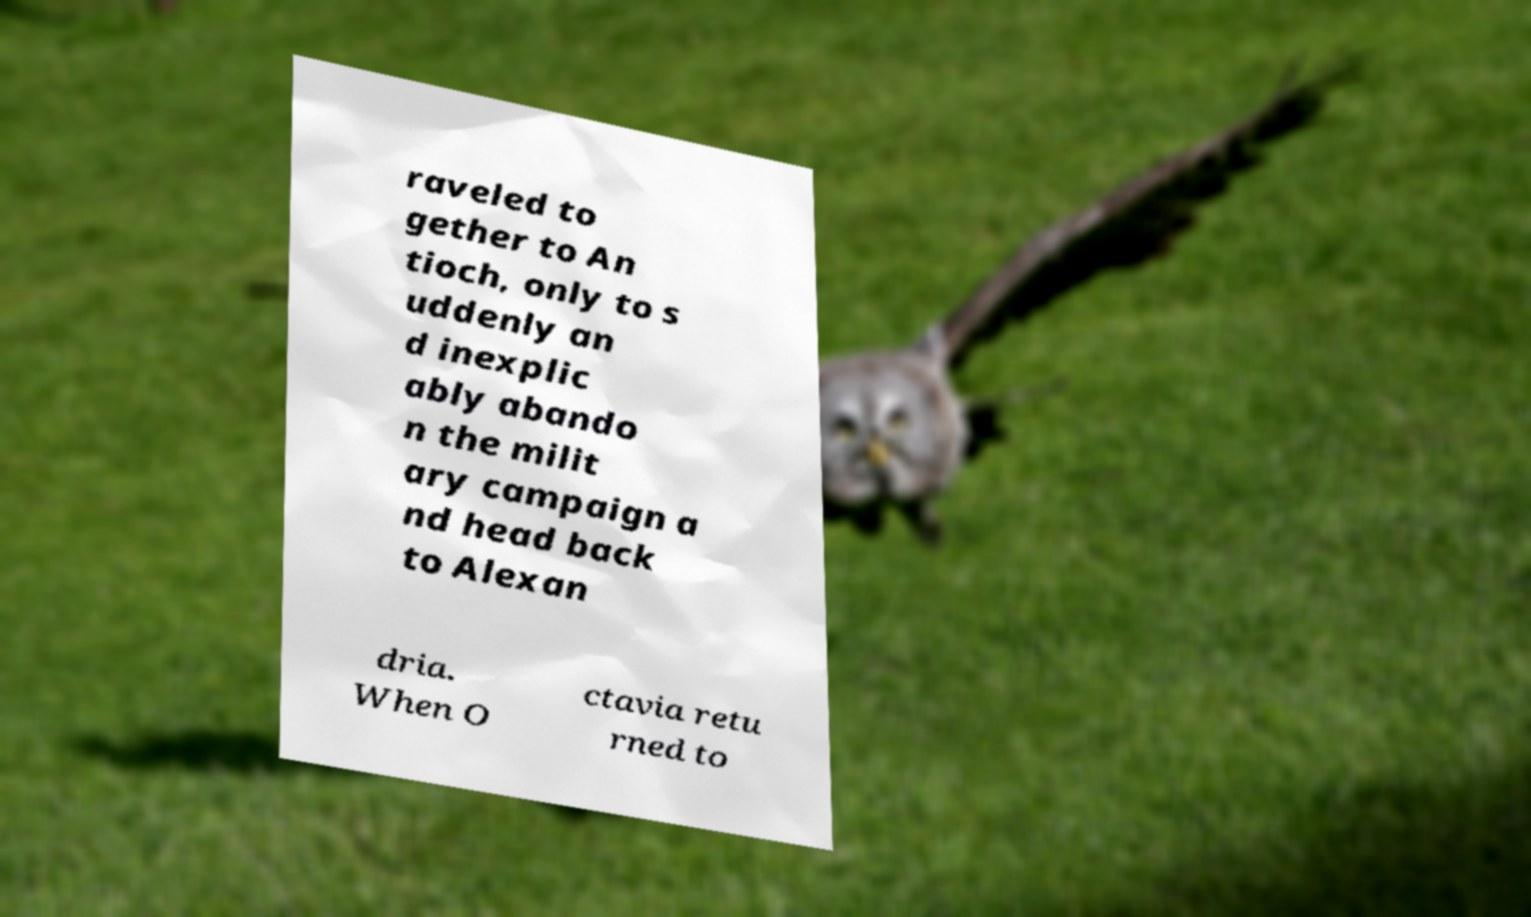Can you accurately transcribe the text from the provided image for me? raveled to gether to An tioch, only to s uddenly an d inexplic ably abando n the milit ary campaign a nd head back to Alexan dria. When O ctavia retu rned to 